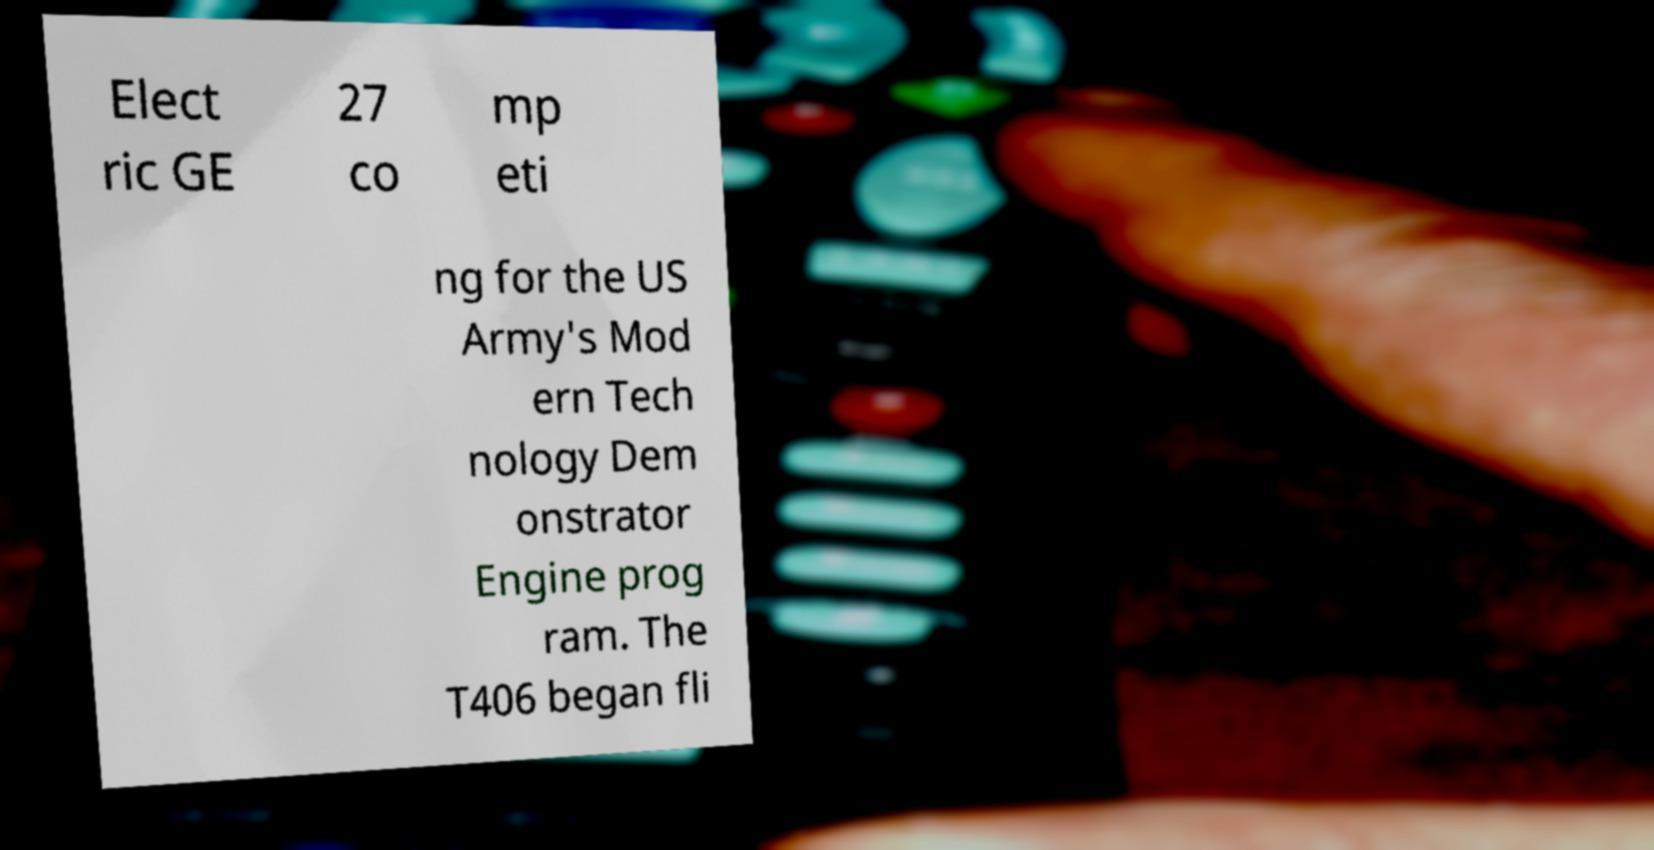Please read and relay the text visible in this image. What does it say? Elect ric GE 27 co mp eti ng for the US Army's Mod ern Tech nology Dem onstrator Engine prog ram. The T406 began fli 